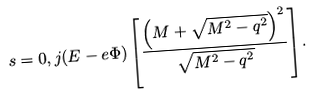<formula> <loc_0><loc_0><loc_500><loc_500>s = 0 , j ( E - e \Phi ) \left [ \frac { \left ( M + \sqrt { M ^ { 2 } - q ^ { 2 } } \right ) ^ { 2 } } { \sqrt { M ^ { 2 } - q ^ { 2 } } } \right ] .</formula> 